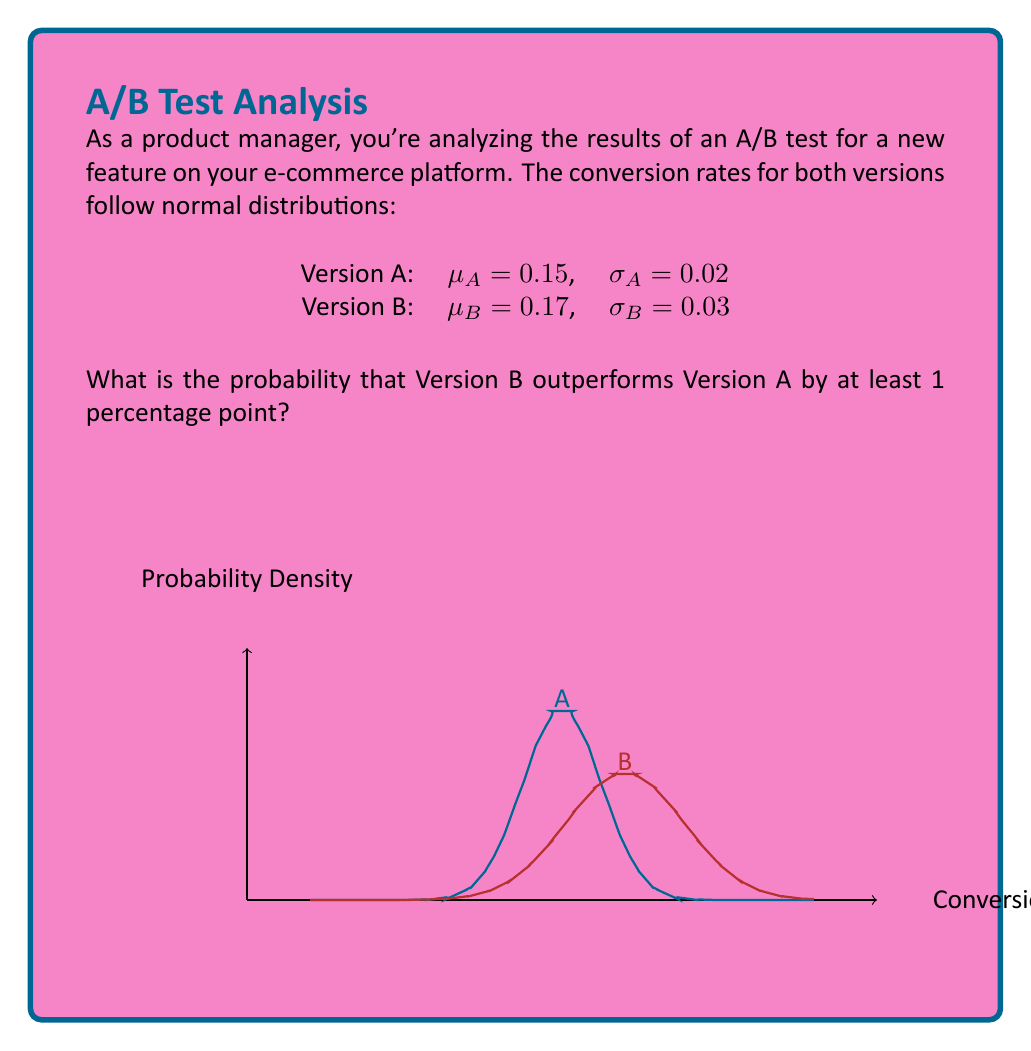Can you answer this question? Let's approach this step-by-step:

1) We need to find $P(B - A \geq 0.01)$, where A and B are normally distributed random variables.

2) The difference of two normally distributed variables is also normally distributed. Let's call this new variable D = B - A.

3) The mean of D is:
   $\mu_D = \mu_B - \mu_A = 0.17 - 0.15 = 0.02$

4) The variance of D is the sum of the variances of A and B:
   $\sigma_D^2 = \sigma_A^2 + \sigma_B^2 = 0.02^2 + 0.03^2 = 0.0004 + 0.0009 = 0.0013$

5) The standard deviation of D is:
   $\sigma_D = \sqrt{0.0013} \approx 0.0360555$

6) Now, we need to find $P(D \geq 0.01)$. We can standardize this:
   $Z = \frac{D - \mu_D}{\sigma_D} = \frac{0.01 - 0.02}{0.0360555} \approx -0.2773$

7) We want $P(Z \geq -0.2773)$, which is equivalent to $1 - P(Z < -0.2773)$

8) Using a standard normal distribution table or calculator:
   $P(Z < -0.2773) \approx 0.3908$

9) Therefore, $P(Z \geq -0.2773) = 1 - 0.3908 = 0.6092$
Answer: 0.6092 or 60.92% 